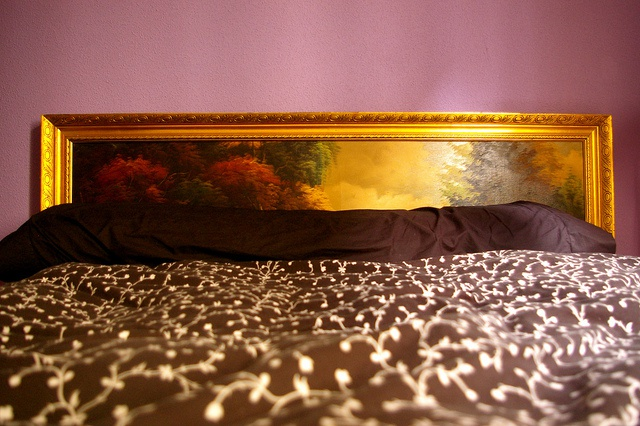Describe the objects in this image and their specific colors. I can see a bed in brown, maroon, black, and gray tones in this image. 